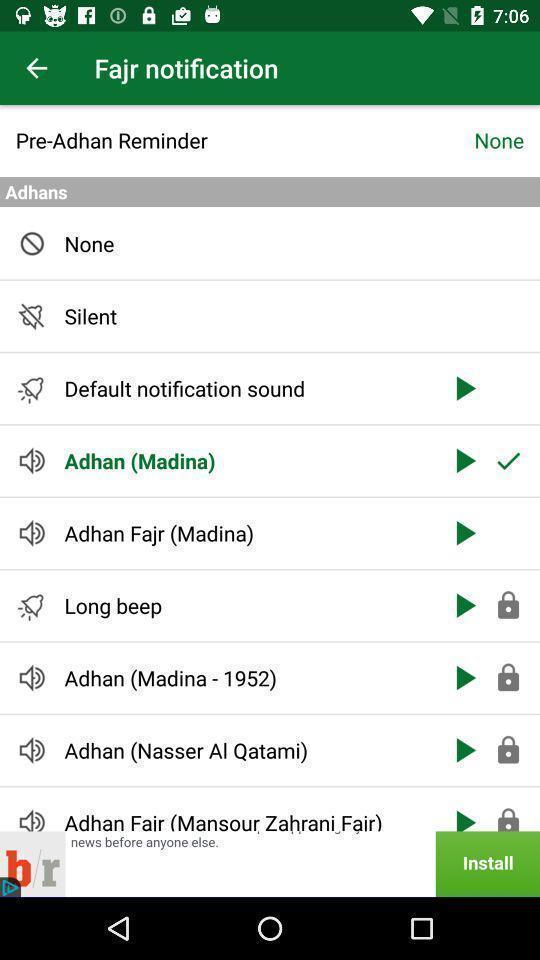What is the overall content of this screenshot? Screen displaying the multiple features. 